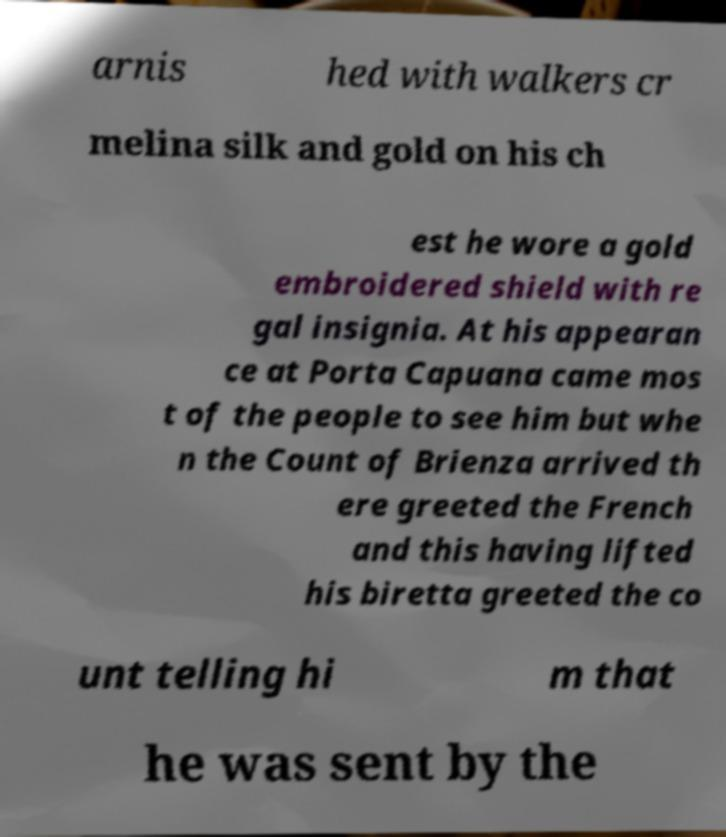I need the written content from this picture converted into text. Can you do that? arnis hed with walkers cr melina silk and gold on his ch est he wore a gold embroidered shield with re gal insignia. At his appearan ce at Porta Capuana came mos t of the people to see him but whe n the Count of Brienza arrived th ere greeted the French and this having lifted his biretta greeted the co unt telling hi m that he was sent by the 